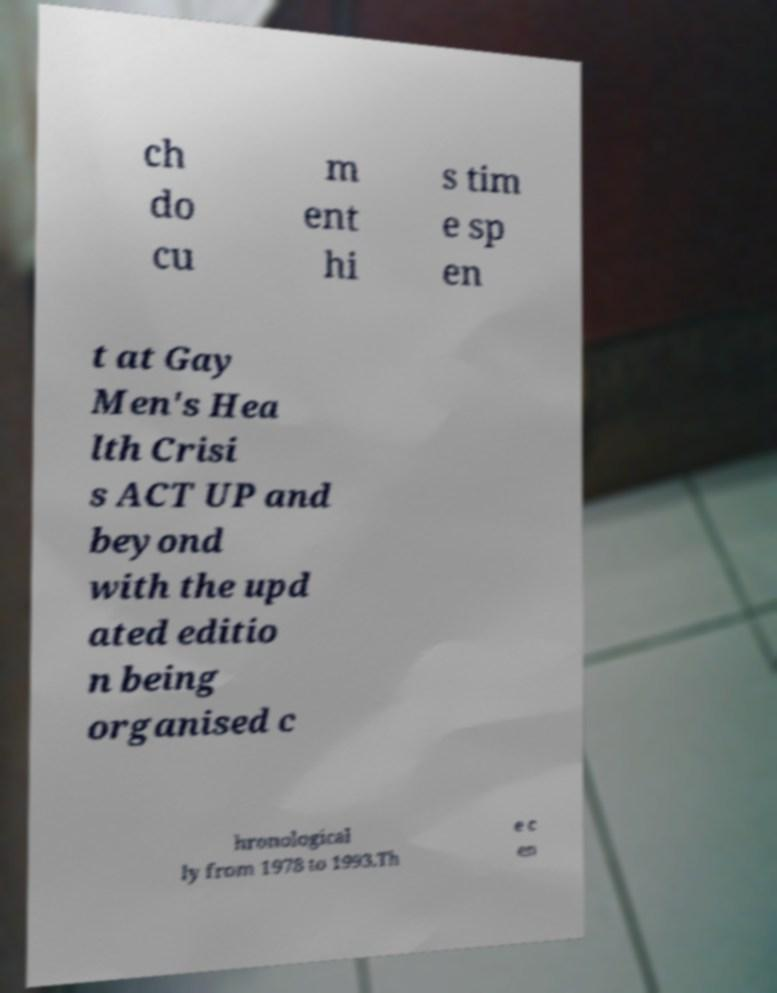Could you assist in decoding the text presented in this image and type it out clearly? ch do cu m ent hi s tim e sp en t at Gay Men's Hea lth Crisi s ACT UP and beyond with the upd ated editio n being organised c hronological ly from 1978 to 1993.Th e c en 